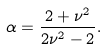<formula> <loc_0><loc_0><loc_500><loc_500>\alpha = \frac { 2 + \nu ^ { 2 } } { 2 \nu ^ { 2 } - 2 } .</formula> 